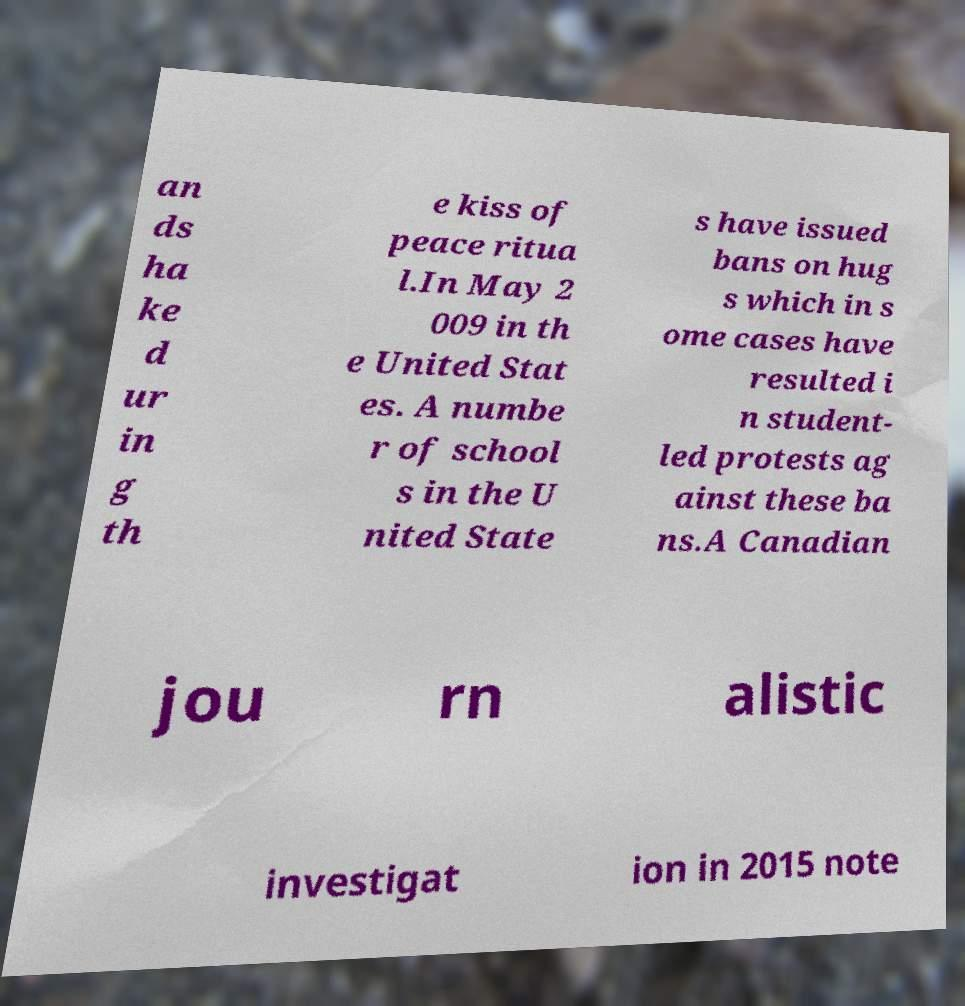What messages or text are displayed in this image? I need them in a readable, typed format. an ds ha ke d ur in g th e kiss of peace ritua l.In May 2 009 in th e United Stat es. A numbe r of school s in the U nited State s have issued bans on hug s which in s ome cases have resulted i n student- led protests ag ainst these ba ns.A Canadian jou rn alistic investigat ion in 2015 note 